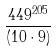Convert formula to latex. <formula><loc_0><loc_0><loc_500><loc_500>\frac { 4 4 9 ^ { 2 0 5 } } { ( 1 0 \cdot 9 ) }</formula> 